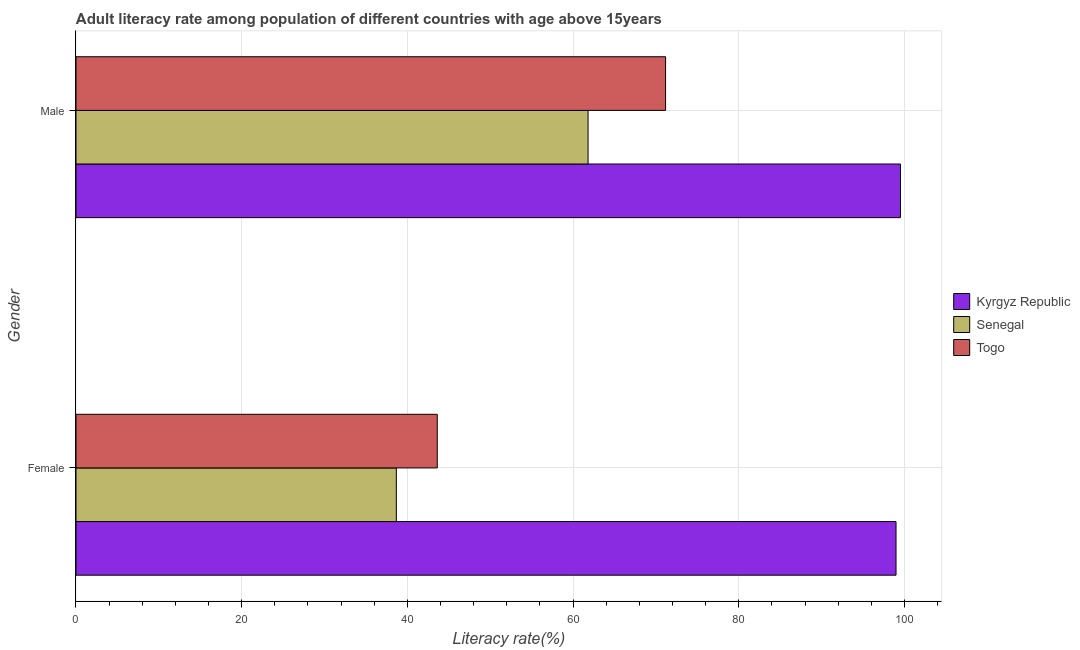How many different coloured bars are there?
Ensure brevity in your answer.  3. Are the number of bars per tick equal to the number of legend labels?
Keep it short and to the point. Yes. How many bars are there on the 1st tick from the bottom?
Offer a terse response. 3. What is the male adult literacy rate in Kyrgyz Republic?
Give a very brief answer. 99.52. Across all countries, what is the maximum male adult literacy rate?
Offer a terse response. 99.52. Across all countries, what is the minimum female adult literacy rate?
Ensure brevity in your answer.  38.67. In which country was the male adult literacy rate maximum?
Ensure brevity in your answer.  Kyrgyz Republic. In which country was the female adult literacy rate minimum?
Offer a terse response. Senegal. What is the total female adult literacy rate in the graph?
Keep it short and to the point. 181.25. What is the difference between the male adult literacy rate in Senegal and that in Togo?
Your answer should be very brief. -9.36. What is the difference between the female adult literacy rate in Togo and the male adult literacy rate in Kyrgyz Republic?
Make the answer very short. -55.91. What is the average male adult literacy rate per country?
Ensure brevity in your answer.  77.5. What is the difference between the female adult literacy rate and male adult literacy rate in Kyrgyz Republic?
Give a very brief answer. -0.53. In how many countries, is the male adult literacy rate greater than 48 %?
Your answer should be compact. 3. What is the ratio of the female adult literacy rate in Togo to that in Kyrgyz Republic?
Ensure brevity in your answer.  0.44. Is the female adult literacy rate in Senegal less than that in Kyrgyz Republic?
Ensure brevity in your answer.  Yes. In how many countries, is the female adult literacy rate greater than the average female adult literacy rate taken over all countries?
Ensure brevity in your answer.  1. What does the 1st bar from the top in Female represents?
Your answer should be compact. Togo. What does the 2nd bar from the bottom in Male represents?
Provide a succinct answer. Senegal. How many bars are there?
Make the answer very short. 6. Are the values on the major ticks of X-axis written in scientific E-notation?
Offer a very short reply. No. Does the graph contain any zero values?
Offer a very short reply. No. Does the graph contain grids?
Give a very brief answer. Yes. Where does the legend appear in the graph?
Your answer should be very brief. Center right. How many legend labels are there?
Offer a terse response. 3. What is the title of the graph?
Give a very brief answer. Adult literacy rate among population of different countries with age above 15years. Does "Somalia" appear as one of the legend labels in the graph?
Ensure brevity in your answer.  No. What is the label or title of the X-axis?
Give a very brief answer. Literacy rate(%). What is the Literacy rate(%) of Kyrgyz Republic in Female?
Your response must be concise. 98.98. What is the Literacy rate(%) in Senegal in Female?
Offer a terse response. 38.67. What is the Literacy rate(%) in Togo in Female?
Give a very brief answer. 43.61. What is the Literacy rate(%) in Kyrgyz Republic in Male?
Make the answer very short. 99.52. What is the Literacy rate(%) of Senegal in Male?
Offer a terse response. 61.81. What is the Literacy rate(%) in Togo in Male?
Keep it short and to the point. 71.17. Across all Gender, what is the maximum Literacy rate(%) in Kyrgyz Republic?
Your answer should be compact. 99.52. Across all Gender, what is the maximum Literacy rate(%) of Senegal?
Your answer should be very brief. 61.81. Across all Gender, what is the maximum Literacy rate(%) in Togo?
Your answer should be compact. 71.17. Across all Gender, what is the minimum Literacy rate(%) in Kyrgyz Republic?
Ensure brevity in your answer.  98.98. Across all Gender, what is the minimum Literacy rate(%) of Senegal?
Provide a short and direct response. 38.67. Across all Gender, what is the minimum Literacy rate(%) in Togo?
Ensure brevity in your answer.  43.61. What is the total Literacy rate(%) of Kyrgyz Republic in the graph?
Your answer should be compact. 198.5. What is the total Literacy rate(%) of Senegal in the graph?
Your answer should be very brief. 100.48. What is the total Literacy rate(%) in Togo in the graph?
Offer a terse response. 114.77. What is the difference between the Literacy rate(%) in Kyrgyz Republic in Female and that in Male?
Your response must be concise. -0.53. What is the difference between the Literacy rate(%) in Senegal in Female and that in Male?
Your answer should be compact. -23.14. What is the difference between the Literacy rate(%) of Togo in Female and that in Male?
Keep it short and to the point. -27.56. What is the difference between the Literacy rate(%) of Kyrgyz Republic in Female and the Literacy rate(%) of Senegal in Male?
Offer a terse response. 37.17. What is the difference between the Literacy rate(%) in Kyrgyz Republic in Female and the Literacy rate(%) in Togo in Male?
Ensure brevity in your answer.  27.81. What is the difference between the Literacy rate(%) in Senegal in Female and the Literacy rate(%) in Togo in Male?
Ensure brevity in your answer.  -32.5. What is the average Literacy rate(%) in Kyrgyz Republic per Gender?
Keep it short and to the point. 99.25. What is the average Literacy rate(%) of Senegal per Gender?
Your response must be concise. 50.24. What is the average Literacy rate(%) of Togo per Gender?
Provide a short and direct response. 57.39. What is the difference between the Literacy rate(%) of Kyrgyz Republic and Literacy rate(%) of Senegal in Female?
Give a very brief answer. 60.31. What is the difference between the Literacy rate(%) of Kyrgyz Republic and Literacy rate(%) of Togo in Female?
Your answer should be very brief. 55.37. What is the difference between the Literacy rate(%) of Senegal and Literacy rate(%) of Togo in Female?
Your answer should be compact. -4.94. What is the difference between the Literacy rate(%) in Kyrgyz Republic and Literacy rate(%) in Senegal in Male?
Your answer should be compact. 37.71. What is the difference between the Literacy rate(%) of Kyrgyz Republic and Literacy rate(%) of Togo in Male?
Give a very brief answer. 28.35. What is the difference between the Literacy rate(%) of Senegal and Literacy rate(%) of Togo in Male?
Your answer should be very brief. -9.36. What is the ratio of the Literacy rate(%) in Senegal in Female to that in Male?
Provide a short and direct response. 0.63. What is the ratio of the Literacy rate(%) in Togo in Female to that in Male?
Your answer should be compact. 0.61. What is the difference between the highest and the second highest Literacy rate(%) in Kyrgyz Republic?
Provide a succinct answer. 0.53. What is the difference between the highest and the second highest Literacy rate(%) in Senegal?
Provide a succinct answer. 23.14. What is the difference between the highest and the second highest Literacy rate(%) in Togo?
Give a very brief answer. 27.56. What is the difference between the highest and the lowest Literacy rate(%) of Kyrgyz Republic?
Ensure brevity in your answer.  0.53. What is the difference between the highest and the lowest Literacy rate(%) in Senegal?
Your response must be concise. 23.14. What is the difference between the highest and the lowest Literacy rate(%) in Togo?
Provide a succinct answer. 27.56. 